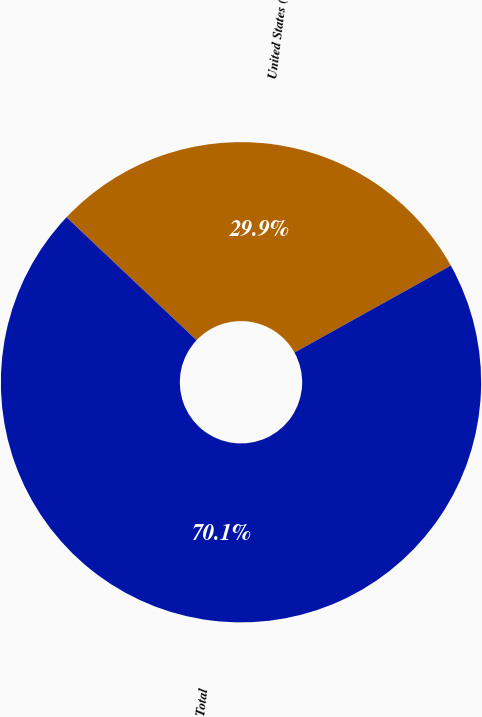Convert chart to OTSL. <chart><loc_0><loc_0><loc_500><loc_500><pie_chart><fcel>United States (b)<fcel>Total<nl><fcel>29.87%<fcel>70.13%<nl></chart> 